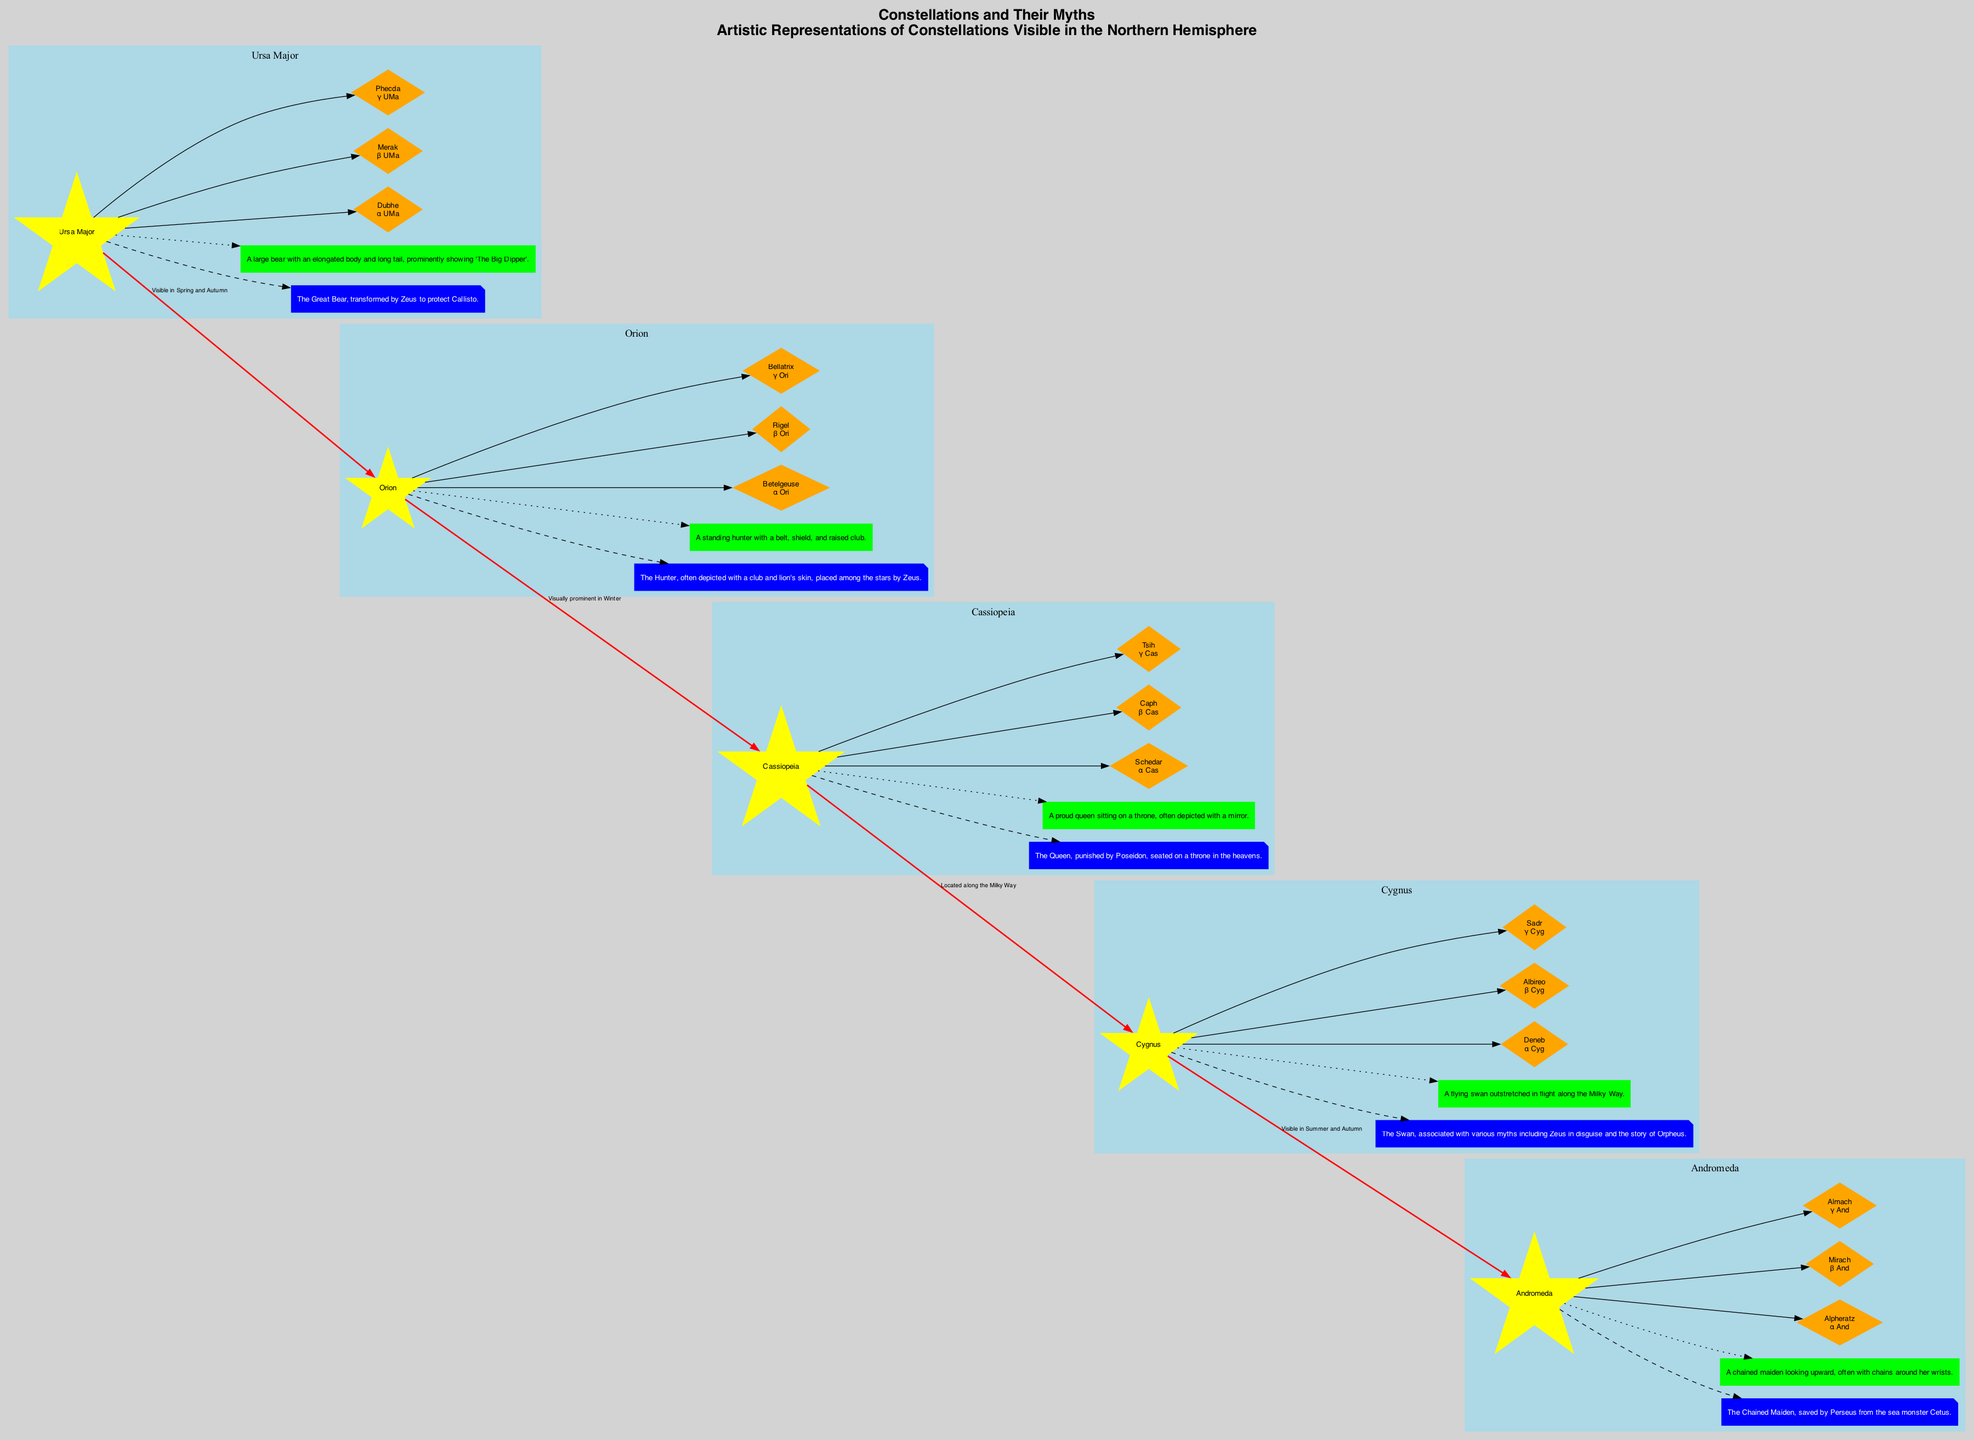What is the myth associated with Orion? The myth associated with Orion is that he is "The Hunter, often depicted with a club and lion's skin, placed among the stars by Zeus." This information is directly stated under the Orion node in the diagram.
Answer: The Hunter, often depicted with a club and lion's skin, placed among the stars by Zeus How many stars are listed for Ursa Major? Ursa Major has three stars listed: Dubhe, Merak, and Phecda. The diagram shows these stars connected to the Ursa Major node, indicating they are the key stars in this constellation.
Answer: Three Which constellation is depicted as a Queen seated on a throne? The constellation depicted as a Queen seated on a throne is Cassiopeia. This description is provided in the artistic representation section of the Cassiopeia node.
Answer: Cassiopeia What is the relationship between Cygnus and Andromeda? The relationship between Cygnus and Andromeda is that Cygnus is "Visible in Summer and Autumn." This relationship is shown by the connecting edge in the diagram, labeled with this information.
Answer: Visible in Summer and Autumn How many constellations are represented in the diagram? There are five constellations represented in the diagram: Ursa Major, Orion, Cassiopeia, Cygnus, and Andromeda. This is determined by counting the nodes labeled with constellation names.
Answer: Five Which constellation contains the star Betelgeuse? Betelgeuse is located in the constellation Orion. The diagram shows Betelgeuse connected to the Orion node, indicating its position in this constellation.
Answer: Orion Describe the artistic representation of Cygnus. The artistic representation of Cygnus is "A flying swan outstretched in flight along the Milky Way." This depiction is directly mentioned in the artistic representation section of the Cygnus node.
Answer: A flying swan outstretched in flight along the Milky Way Which constellation is linked to Cassiopeia and is prominent in Winter? The constellation linked to Cassiopeia and prominent in Winter is Orion. The diagram illustrates this connection through the edge that describes their visual prominence.
Answer: Orion What color represents the myth in the legend? The color representing the myth in the legend is blue. This can be found in the legend section of the diagram, which specifies colors for different elements.
Answer: Blue 